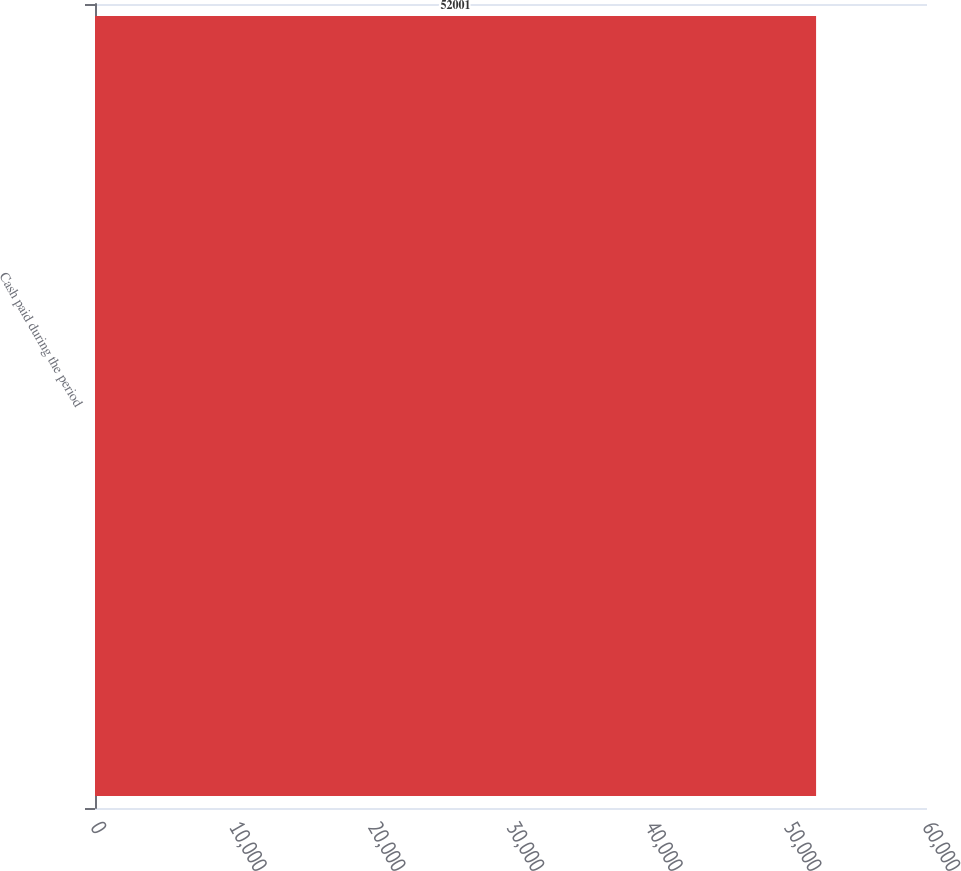Convert chart to OTSL. <chart><loc_0><loc_0><loc_500><loc_500><bar_chart><fcel>Cash paid during the period<nl><fcel>52001<nl></chart> 